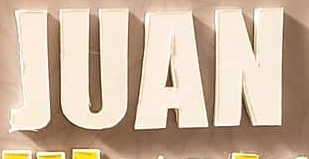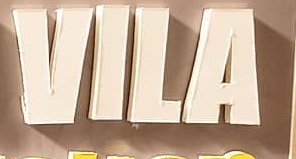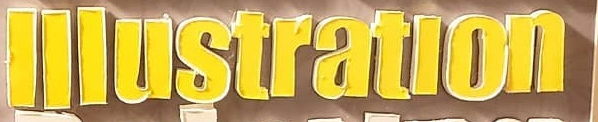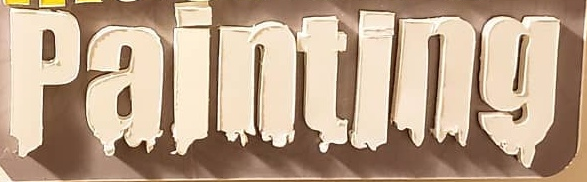What words are shown in these images in order, separated by a semicolon? JUAN; VILA; lllustratlon; painting 